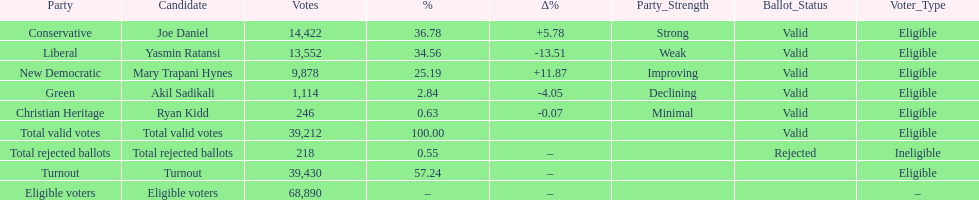Which candidate had the most votes? Joe Daniel. 